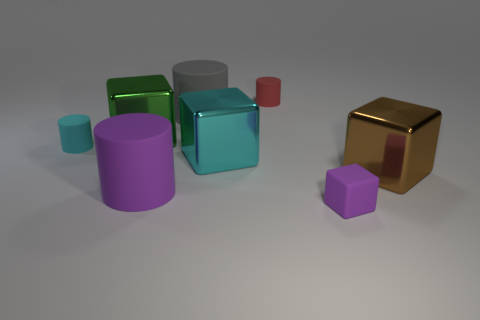Subtract 1 cylinders. How many cylinders are left? 3 Subtract all yellow cubes. Subtract all gray cylinders. How many cubes are left? 4 Add 2 large purple matte cylinders. How many objects exist? 10 Add 7 large green things. How many large green things are left? 8 Add 3 tiny cyan things. How many tiny cyan things exist? 4 Subtract 1 gray cylinders. How many objects are left? 7 Subtract all small cubes. Subtract all large purple shiny spheres. How many objects are left? 7 